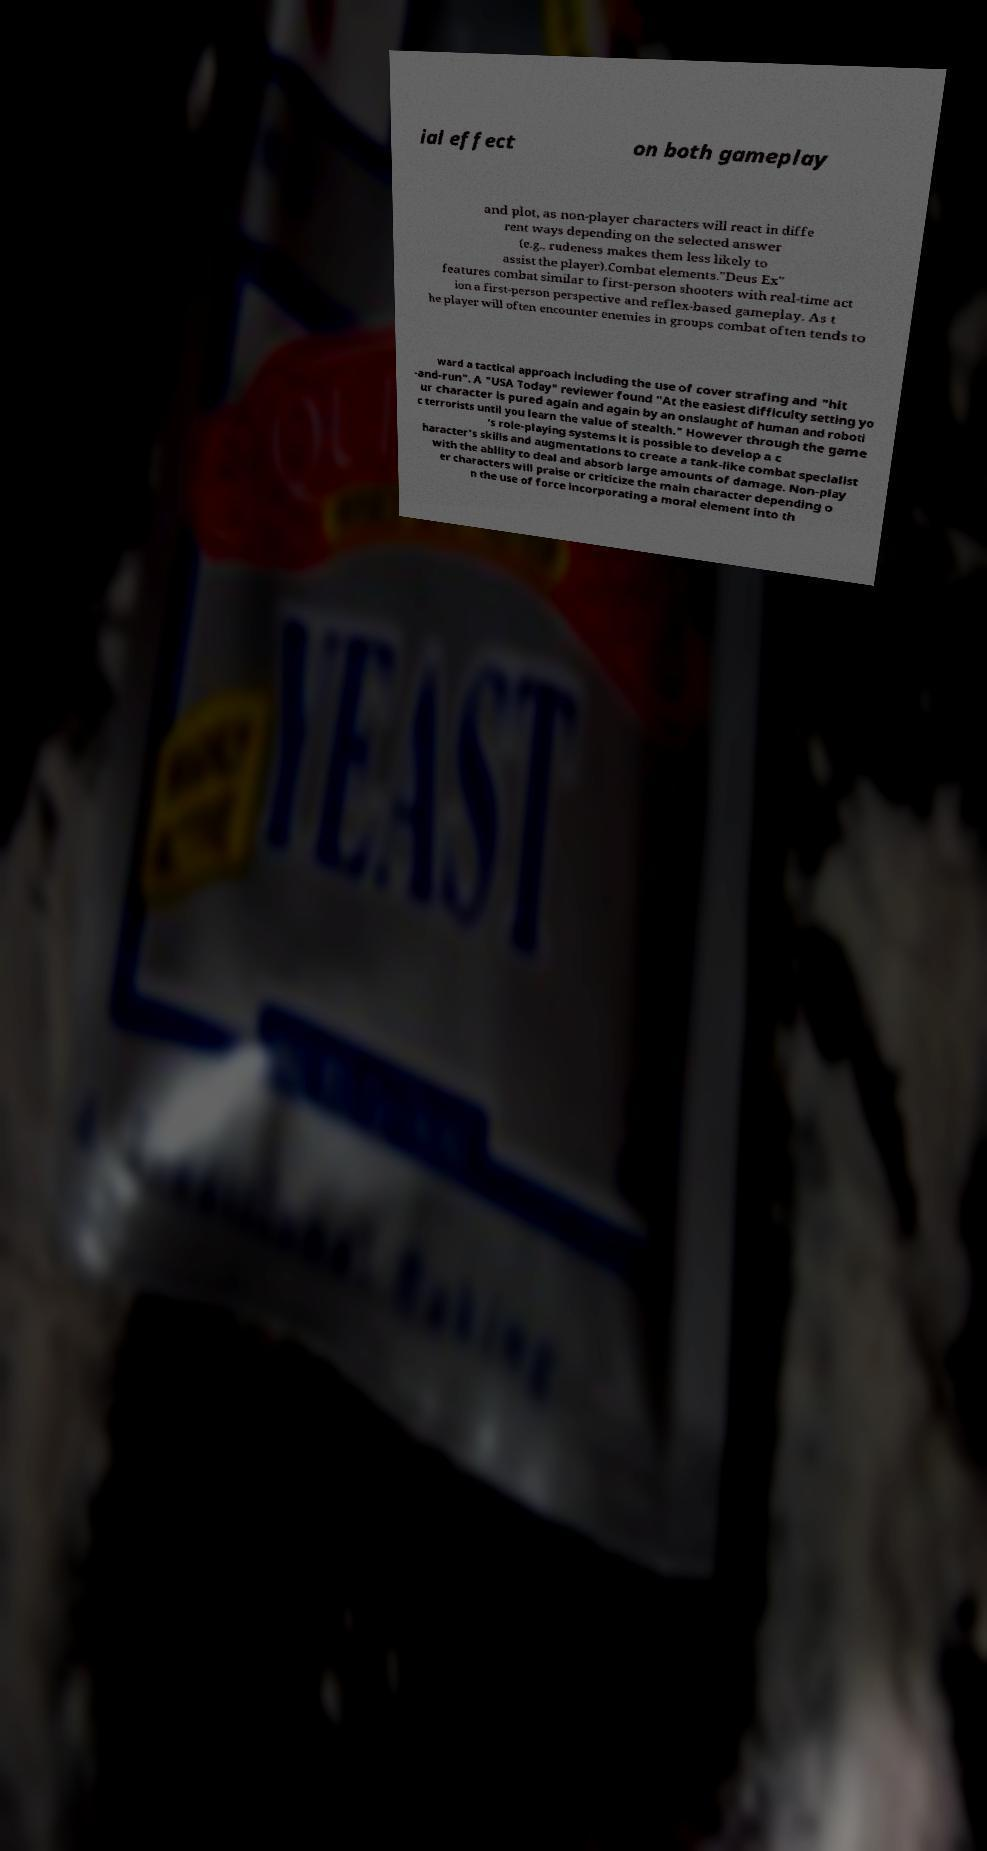Please read and relay the text visible in this image. What does it say? ial effect on both gameplay and plot, as non-player characters will react in diffe rent ways depending on the selected answer (e.g., rudeness makes them less likely to assist the player).Combat elements."Deus Ex" features combat similar to first-person shooters with real-time act ion a first-person perspective and reflex-based gameplay. As t he player will often encounter enemies in groups combat often tends to ward a tactical approach including the use of cover strafing and "hit -and-run". A "USA Today" reviewer found "At the easiest difficulty setting yo ur character is pured again and again by an onslaught of human and roboti c terrorists until you learn the value of stealth." However through the game 's role-playing systems it is possible to develop a c haracter's skills and augmentations to create a tank-like combat specialist with the ability to deal and absorb large amounts of damage. Non-play er characters will praise or criticize the main character depending o n the use of force incorporating a moral element into th 